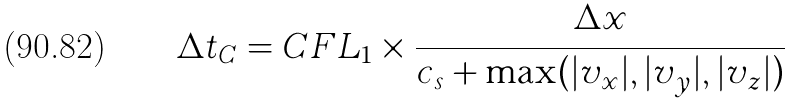<formula> <loc_0><loc_0><loc_500><loc_500>\Delta t _ { C } = C F L _ { 1 } \times \frac { \Delta x } { c _ { s } + \max ( | v _ { x } | , | v _ { y } | , | v _ { z } | ) }</formula> 